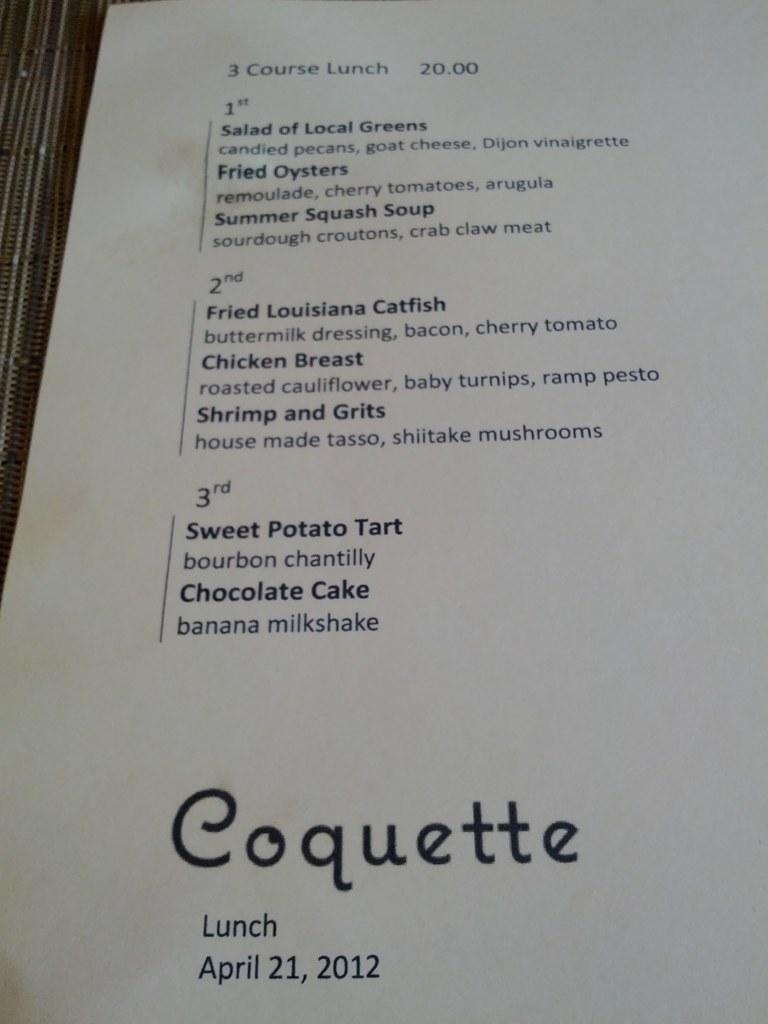<image>
Give a short and clear explanation of the subsequent image. A paper menu for lunch at Coquette from April 21, 2012.. 